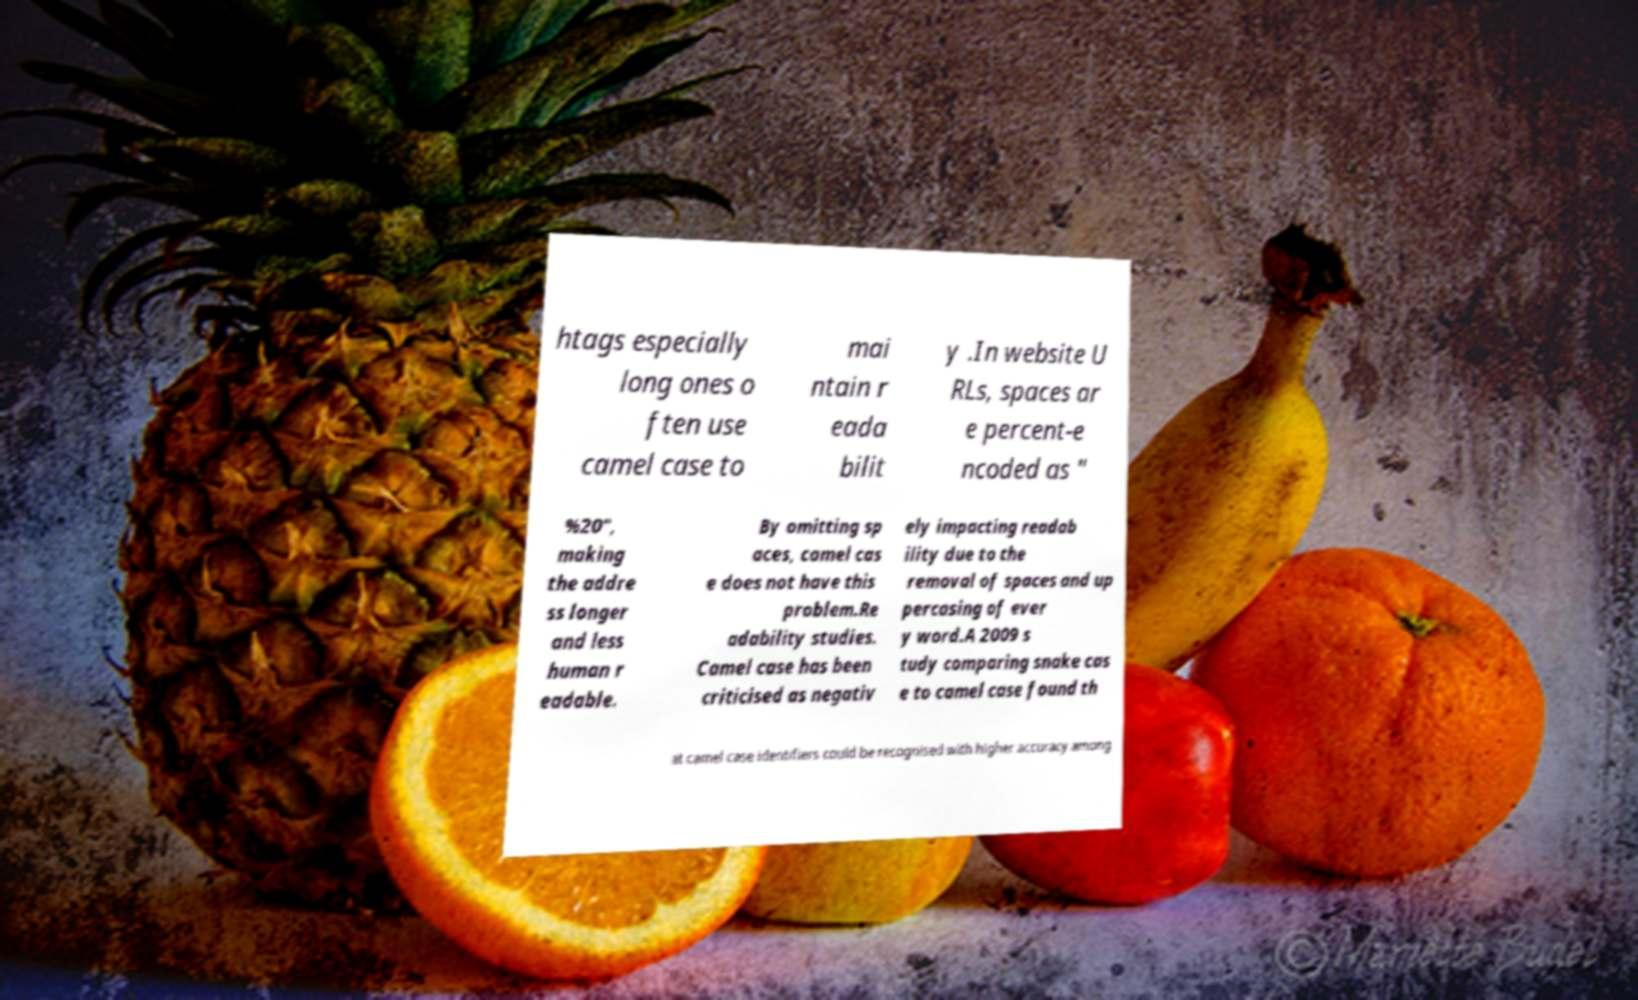There's text embedded in this image that I need extracted. Can you transcribe it verbatim? htags especially long ones o ften use camel case to mai ntain r eada bilit y .In website U RLs, spaces ar e percent-e ncoded as " %20", making the addre ss longer and less human r eadable. By omitting sp aces, camel cas e does not have this problem.Re adability studies. Camel case has been criticised as negativ ely impacting readab ility due to the removal of spaces and up percasing of ever y word.A 2009 s tudy comparing snake cas e to camel case found th at camel case identifiers could be recognised with higher accuracy among 